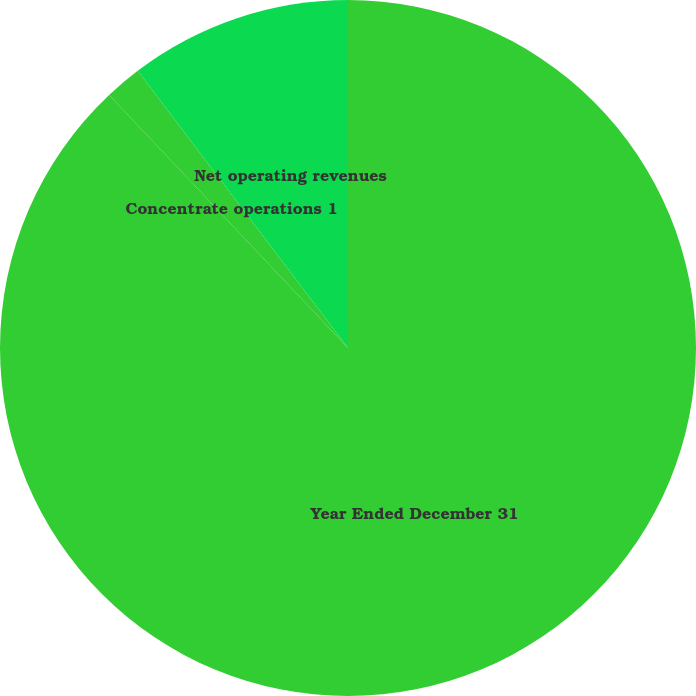<chart> <loc_0><loc_0><loc_500><loc_500><pie_chart><fcel>Year Ended December 31<fcel>Concentrate operations 1<fcel>Net operating revenues<nl><fcel>87.96%<fcel>1.71%<fcel>10.33%<nl></chart> 